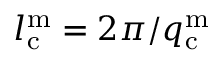Convert formula to latex. <formula><loc_0><loc_0><loc_500><loc_500>l _ { c } ^ { m } = 2 \pi / q _ { c } ^ { m }</formula> 